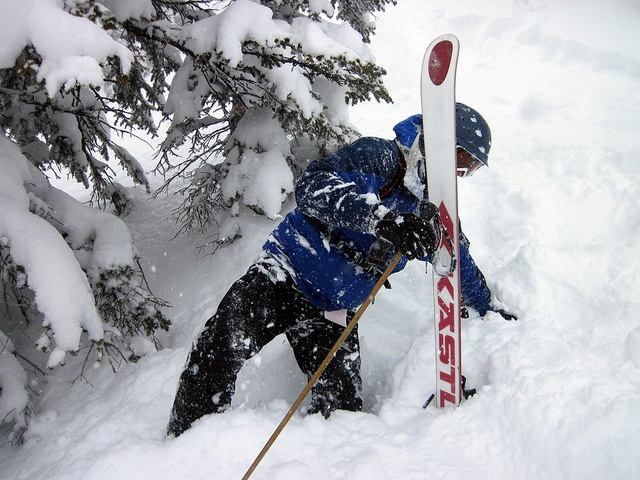Describe the objects in this image and their specific colors. I can see people in lightgray, black, navy, and gray tones and skis in lightgray, darkgray, and brown tones in this image. 